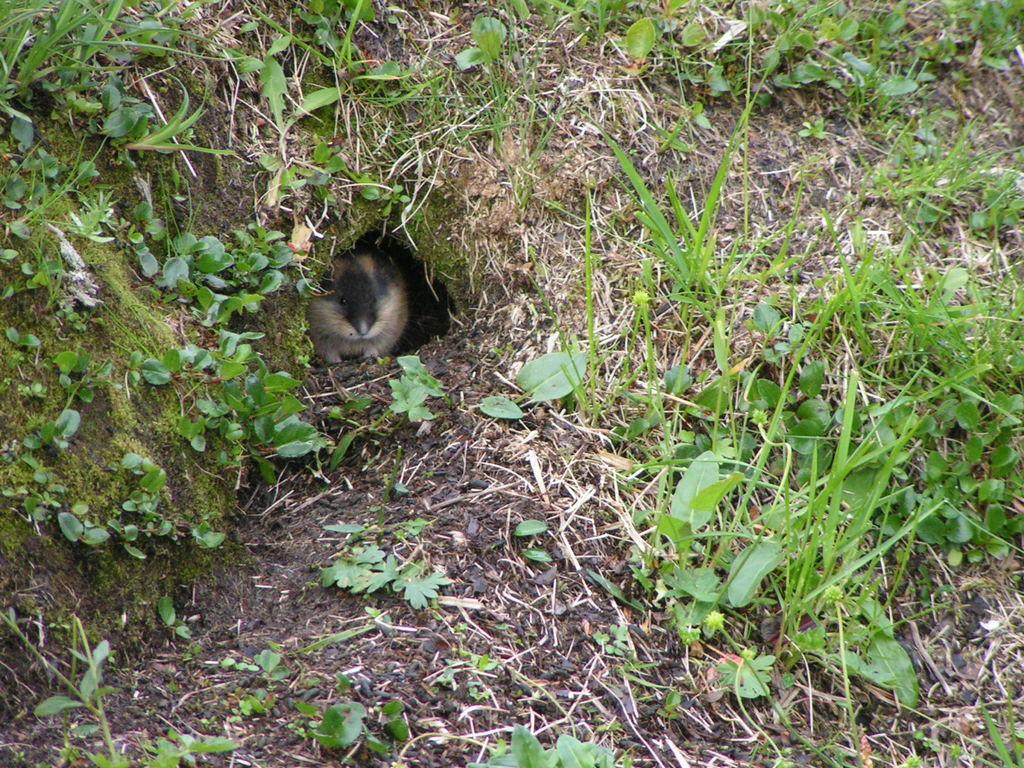What type of animal can be seen in the burrow in the image? There is an animal in the burrow in the image. What can be seen in the background of the image? There are plants and grass in the background of the image. What type of pen is the animal using to write a caption in the image? There is no pen or caption present in the image; it features an animal in a burrow with plants and grass in the background. 